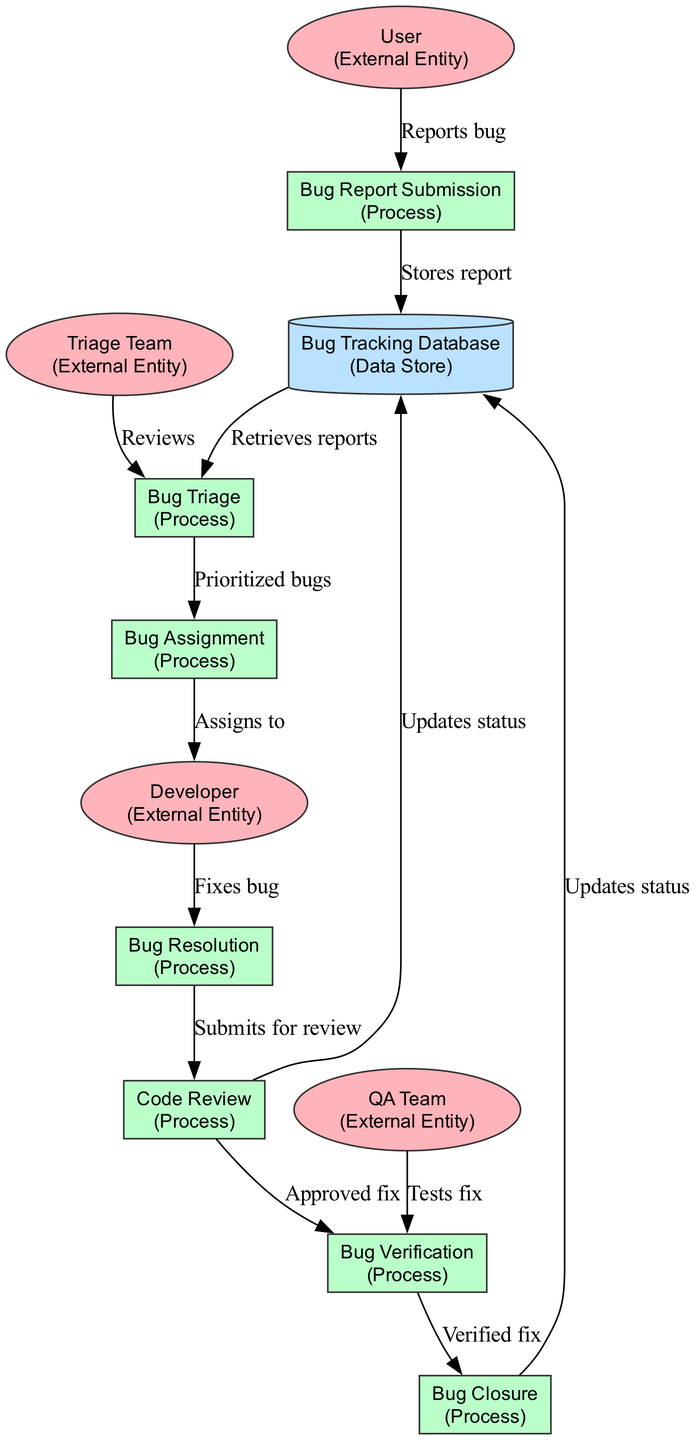What is the starting external entity in the diagram? The diagram begins with the 'User' node as it is the first external entity mentioned. According to the diagram structure, it is highlighted as the origin of the bug reporting process.
Answer: User How many processes are in the diagram? The diagram includes a total of six processes: Bug Report Submission, Bug Triage, Bug Assignment, Bug Resolution, Code Review, and Bug Verification. Counting these nodes gives the total number of processes.
Answer: 6 Which external entity reviews the bugs before prioritization? The 'Triage Team' is the external entity responsible for reviewing reported bugs prior to their prioritization in the 'Bug Triage' process. The diagram indicates a direct connection from this entity to the review process.
Answer: Triage Team What action does a developer take after being assigned a bug? After being assigned a bug, the developer 'fixes the bug' as indicated by the connection from the 'Bug Assignment' process to the 'Bug Resolution' process.
Answer: Fixes bug What is the relationship between the 'Code Review' and 'Bug Verification' processes? The 'Code Review' process occurs after 'Bug Resolution' and before 'Bug Verification', meaning the code must be reviewed prior to being tested by the QA Team. This sequential flow establishes the relationship between these two processes.
Answer: Sequential flow Which data store holds the bug reports? The 'Bug Tracking Database' is the data store that holds all the bug reports and related data as established by the 'Stores report' edge from the 'Bug Report Submission' process.
Answer: Bug Tracking Database How many external entities are involved in the pipeline? There are four external entities involved: User, Triage Team, Developer, and QA Team. This can be verified by counting all nodes classified as external entities in the diagram.
Answer: 4 What occurs after the bug is verified? After verification, the next process is 'Bug Closure', which marks the resolved and verified bug as closed according to the flow of activities depicted in the diagram.
Answer: Bug Closure 